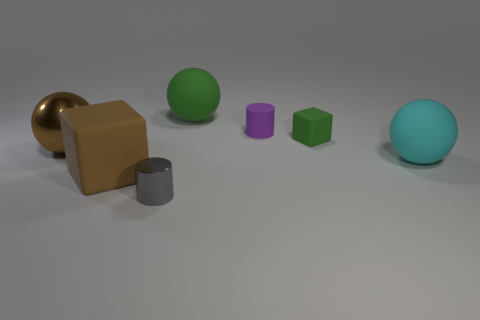How many gray cylinders are there?
Make the answer very short. 1. What number of green objects are the same shape as the cyan matte object?
Offer a terse response. 1. Does the large brown shiny thing have the same shape as the big cyan object?
Provide a succinct answer. Yes. What size is the purple thing?
Give a very brief answer. Small. What number of brown cubes are the same size as the metal cylinder?
Your answer should be compact. 0. Do the cylinder that is behind the gray metallic cylinder and the matte thing to the left of the big green matte object have the same size?
Provide a succinct answer. No. There is a green matte thing in front of the purple cylinder; what is its shape?
Your answer should be very brief. Cube. What material is the small cylinder that is to the left of the rubber ball that is behind the green block?
Provide a succinct answer. Metal. Are there any metallic blocks that have the same color as the large matte block?
Ensure brevity in your answer.  No. Do the brown matte thing and the cylinder that is in front of the tiny purple matte object have the same size?
Make the answer very short. No. 